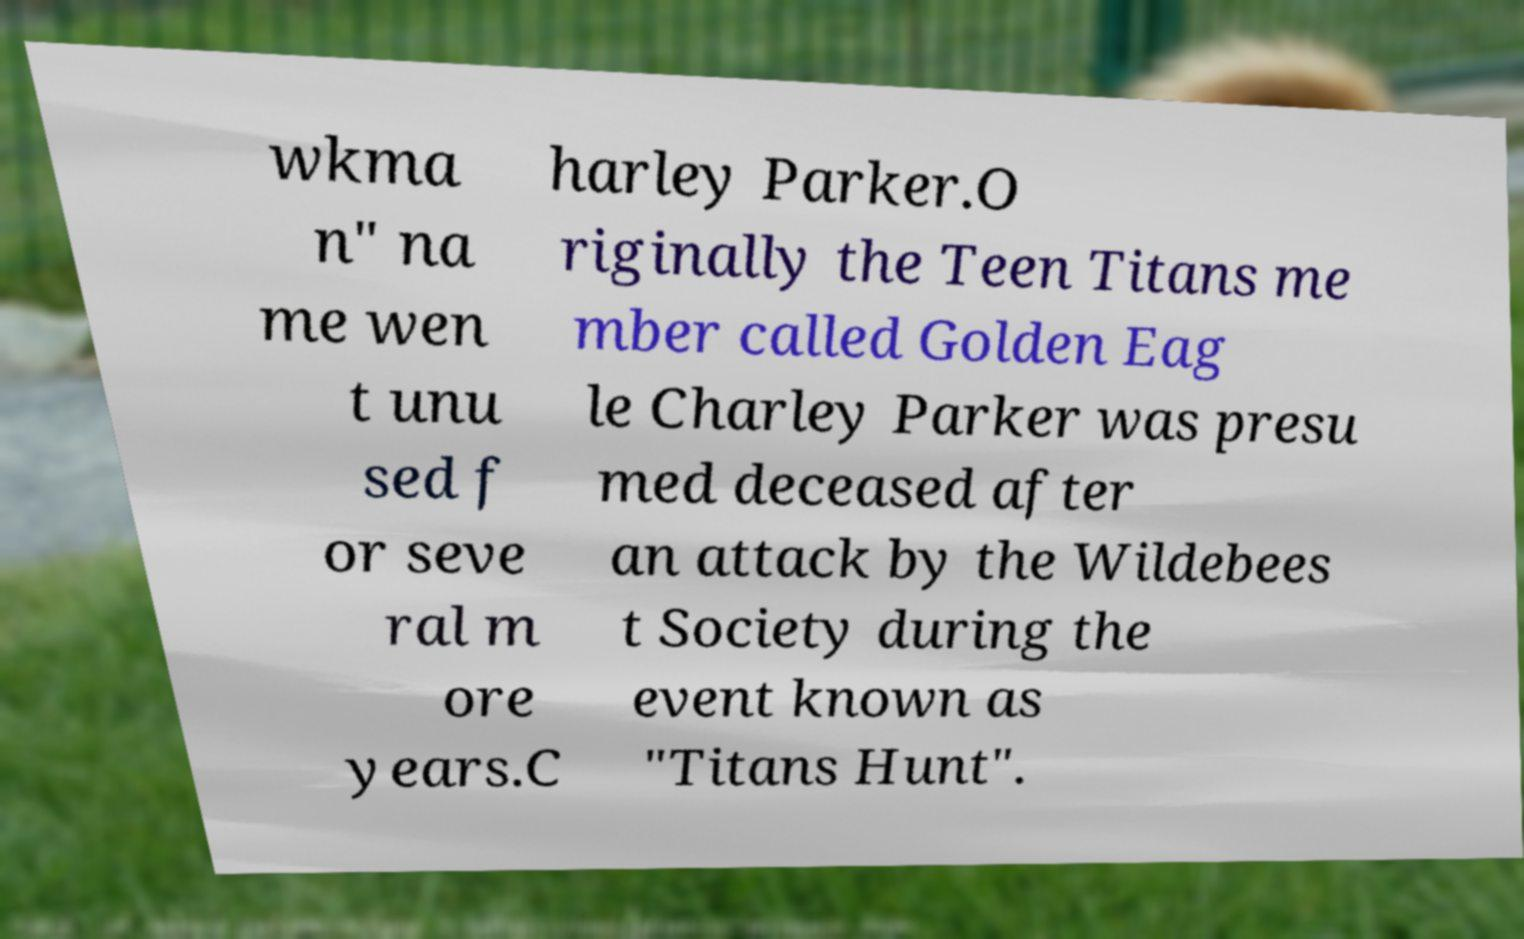There's text embedded in this image that I need extracted. Can you transcribe it verbatim? wkma n" na me wen t unu sed f or seve ral m ore years.C harley Parker.O riginally the Teen Titans me mber called Golden Eag le Charley Parker was presu med deceased after an attack by the Wildebees t Society during the event known as "Titans Hunt". 